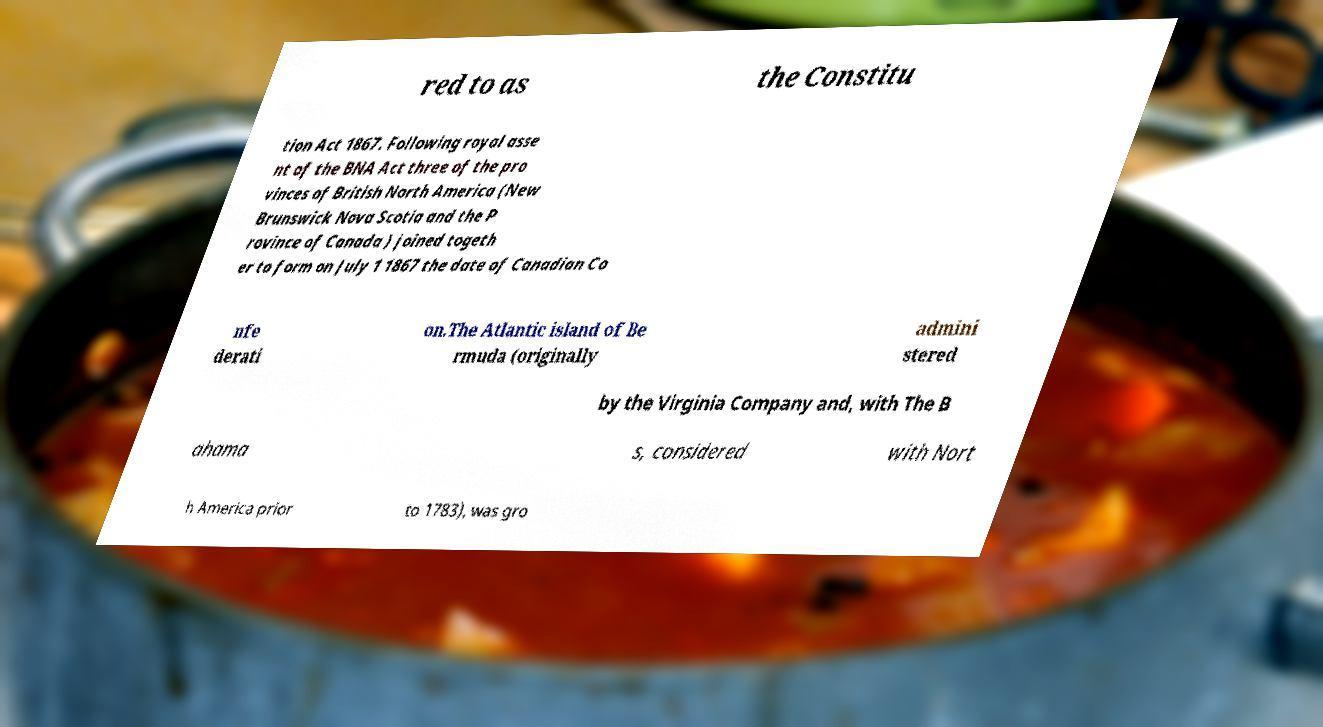I need the written content from this picture converted into text. Can you do that? red to as the Constitu tion Act 1867. Following royal asse nt of the BNA Act three of the pro vinces of British North America (New Brunswick Nova Scotia and the P rovince of Canada ) joined togeth er to form on July 1 1867 the date of Canadian Co nfe derati on.The Atlantic island of Be rmuda (originally admini stered by the Virginia Company and, with The B ahama s, considered with Nort h America prior to 1783), was gro 